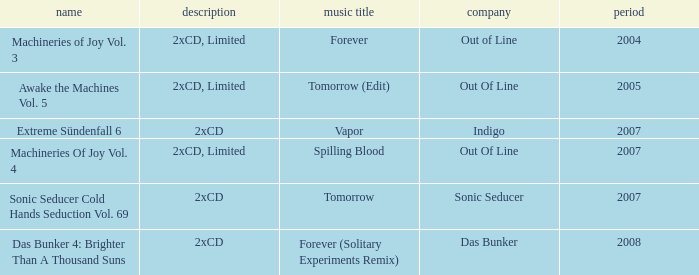Which details has the out of line label and the year of 2005? 2xCD, Limited. 